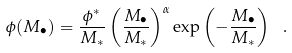<formula> <loc_0><loc_0><loc_500><loc_500>\phi ( M _ { \bullet } ) = \frac { \phi ^ { * } } { M _ { * } } \left ( \frac { M _ { \bullet } } { M _ { * } } \right ) ^ { \alpha } \exp \left ( - \frac { M _ { \bullet } } { M _ { * } } \right ) \ .</formula> 